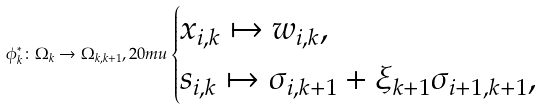Convert formula to latex. <formula><loc_0><loc_0><loc_500><loc_500>\phi _ { k } ^ { * } \colon \Omega _ { k } \to \Omega _ { k , k + 1 } , { 2 0 m u } \begin{cases} x _ { i , k } \mapsto w _ { i , k } , \\ s _ { i , k } \mapsto \sigma _ { i , k + 1 } + \xi _ { k + 1 } \sigma _ { i + 1 , k + 1 } , \end{cases}</formula> 